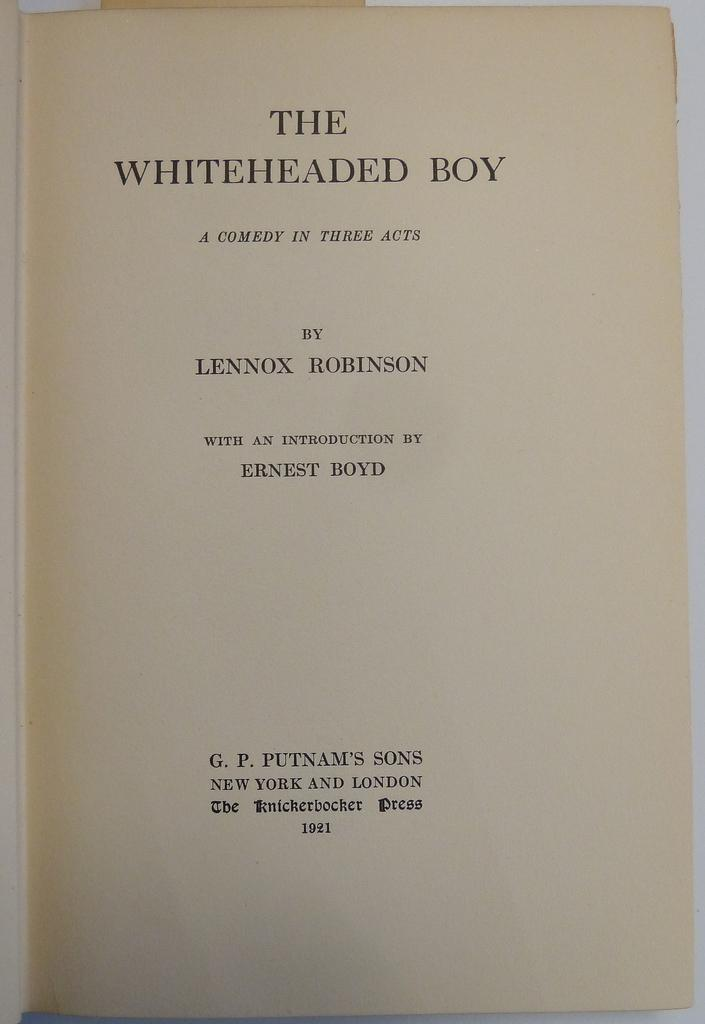Provide a one-sentence caption for the provided image. A book titled The Whiteheaded Boy by the author Lennox Robinson. 